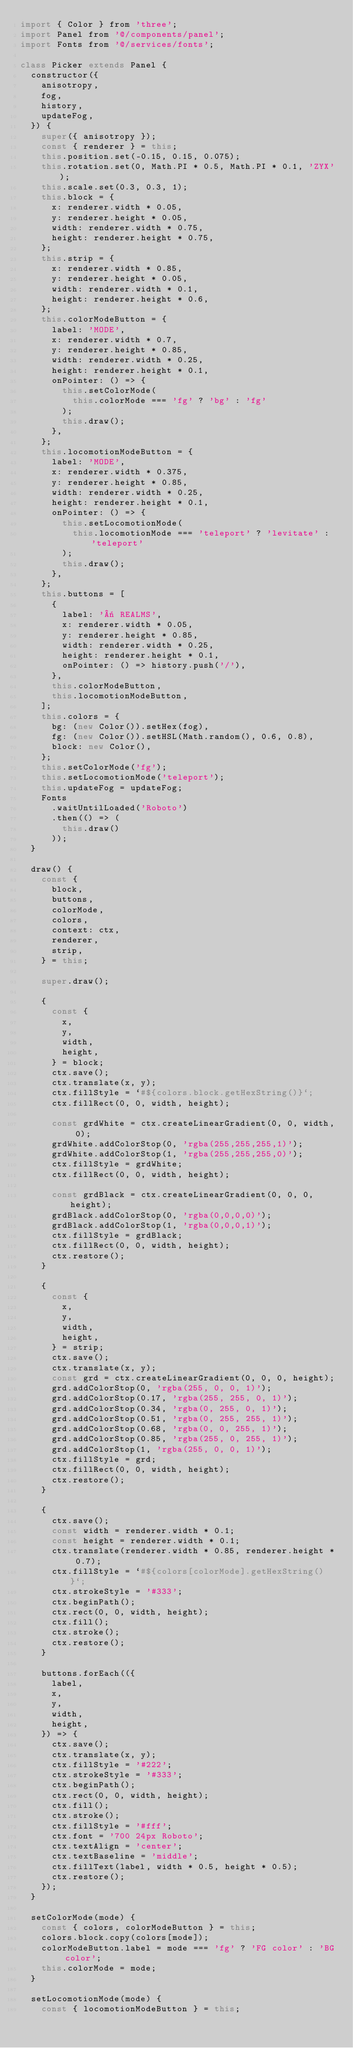Convert code to text. <code><loc_0><loc_0><loc_500><loc_500><_JavaScript_>import { Color } from 'three';
import Panel from '@/components/panel';
import Fonts from '@/services/fonts';

class Picker extends Panel {
  constructor({
    anisotropy,
    fog,
    history,
    updateFog,
  }) {
    super({ anisotropy });
    const { renderer } = this;
    this.position.set(-0.15, 0.15, 0.075);
    this.rotation.set(0, Math.PI * 0.5, Math.PI * 0.1, 'ZYX');
    this.scale.set(0.3, 0.3, 1);
    this.block = {
      x: renderer.width * 0.05,
      y: renderer.height * 0.05,
      width: renderer.width * 0.75,
      height: renderer.height * 0.75,
    };
    this.strip = {
      x: renderer.width * 0.85,
      y: renderer.height * 0.05,
      width: renderer.width * 0.1,
      height: renderer.height * 0.6,
    };
    this.colorModeButton = {
      label: 'MODE',
      x: renderer.width * 0.7,
      y: renderer.height * 0.85,
      width: renderer.width * 0.25,
      height: renderer.height * 0.1,
      onPointer: () => {
        this.setColorMode(
          this.colorMode === 'fg' ? 'bg' : 'fg'
        );
        this.draw();
      },
    };
    this.locomotionModeButton = {
      label: 'MODE',
      x: renderer.width * 0.375,
      y: renderer.height * 0.85,
      width: renderer.width * 0.25,
      height: renderer.height * 0.1,
      onPointer: () => {
        this.setLocomotionMode(
          this.locomotionMode === 'teleport' ? 'levitate' : 'teleport'
        );
        this.draw();
      },
    };
    this.buttons = [
      {
        label: '« REALMS',
        x: renderer.width * 0.05,
        y: renderer.height * 0.85,
        width: renderer.width * 0.25,
        height: renderer.height * 0.1,
        onPointer: () => history.push('/'),
      },
      this.colorModeButton,
      this.locomotionModeButton,
    ];
    this.colors = {
      bg: (new Color()).setHex(fog),
      fg: (new Color()).setHSL(Math.random(), 0.6, 0.8),
      block: new Color(),
    };
    this.setColorMode('fg');
    this.setLocomotionMode('teleport');
    this.updateFog = updateFog;
    Fonts
      .waitUntilLoaded('Roboto')
      .then(() => (
        this.draw()
      ));
  }

  draw() {
    const {
      block,
      buttons,
      colorMode,
      colors,
      context: ctx,
      renderer,
      strip,
    } = this;

    super.draw();

    {
      const {
        x,
        y,
        width,
        height,
      } = block;
      ctx.save();
      ctx.translate(x, y);
      ctx.fillStyle = `#${colors.block.getHexString()}`;
      ctx.fillRect(0, 0, width, height);

      const grdWhite = ctx.createLinearGradient(0, 0, width, 0);
      grdWhite.addColorStop(0, 'rgba(255,255,255,1)');
      grdWhite.addColorStop(1, 'rgba(255,255,255,0)');
      ctx.fillStyle = grdWhite;
      ctx.fillRect(0, 0, width, height);

      const grdBlack = ctx.createLinearGradient(0, 0, 0, height);
      grdBlack.addColorStop(0, 'rgba(0,0,0,0)');
      grdBlack.addColorStop(1, 'rgba(0,0,0,1)');
      ctx.fillStyle = grdBlack;
      ctx.fillRect(0, 0, width, height);
      ctx.restore();
    }

    {
      const {
        x,
        y,
        width,
        height,
      } = strip;
      ctx.save();
      ctx.translate(x, y);
      const grd = ctx.createLinearGradient(0, 0, 0, height);
      grd.addColorStop(0, 'rgba(255, 0, 0, 1)');
      grd.addColorStop(0.17, 'rgba(255, 255, 0, 1)');
      grd.addColorStop(0.34, 'rgba(0, 255, 0, 1)');
      grd.addColorStop(0.51, 'rgba(0, 255, 255, 1)');
      grd.addColorStop(0.68, 'rgba(0, 0, 255, 1)');
      grd.addColorStop(0.85, 'rgba(255, 0, 255, 1)');
      grd.addColorStop(1, 'rgba(255, 0, 0, 1)');
      ctx.fillStyle = grd;
      ctx.fillRect(0, 0, width, height);
      ctx.restore();
    }

    {
      ctx.save();
      const width = renderer.width * 0.1;
      const height = renderer.width * 0.1;
      ctx.translate(renderer.width * 0.85, renderer.height * 0.7);
      ctx.fillStyle = `#${colors[colorMode].getHexString()}`;
      ctx.strokeStyle = '#333';
      ctx.beginPath();
      ctx.rect(0, 0, width, height);
      ctx.fill();
      ctx.stroke();
      ctx.restore();
    }

    buttons.forEach(({
      label,
      x,
      y,
      width,
      height,
    }) => {
      ctx.save();
      ctx.translate(x, y);
      ctx.fillStyle = '#222';
      ctx.strokeStyle = '#333';
      ctx.beginPath();
      ctx.rect(0, 0, width, height);
      ctx.fill();
      ctx.stroke();
      ctx.fillStyle = '#fff';
      ctx.font = '700 24px Roboto';
      ctx.textAlign = 'center';
      ctx.textBaseline = 'middle';
      ctx.fillText(label, width * 0.5, height * 0.5);
      ctx.restore();
    });
  }

  setColorMode(mode) {
    const { colors, colorModeButton } = this;
    colors.block.copy(colors[mode]);
    colorModeButton.label = mode === 'fg' ? 'FG color' : 'BG color';
    this.colorMode = mode;
  }

  setLocomotionMode(mode) {
    const { locomotionModeButton } = this;</code> 